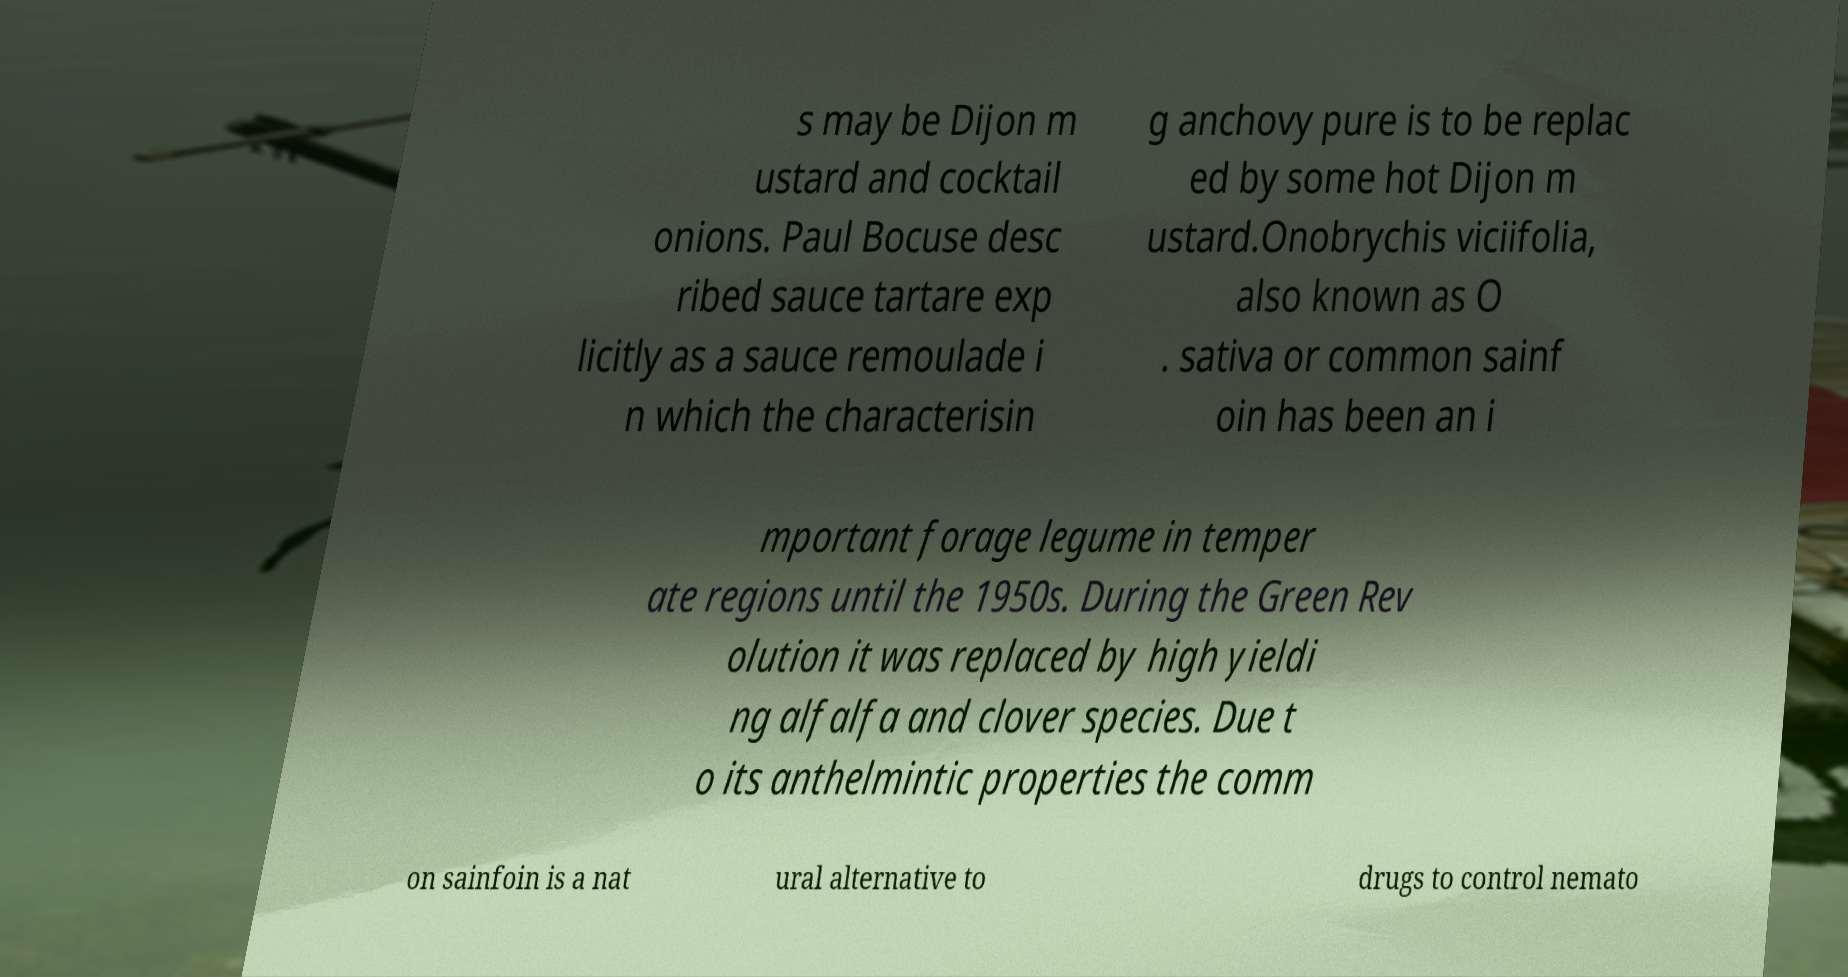Can you accurately transcribe the text from the provided image for me? s may be Dijon m ustard and cocktail onions. Paul Bocuse desc ribed sauce tartare exp licitly as a sauce remoulade i n which the characterisin g anchovy pure is to be replac ed by some hot Dijon m ustard.Onobrychis viciifolia, also known as O . sativa or common sainf oin has been an i mportant forage legume in temper ate regions until the 1950s. During the Green Rev olution it was replaced by high yieldi ng alfalfa and clover species. Due t o its anthelmintic properties the comm on sainfoin is a nat ural alternative to drugs to control nemato 